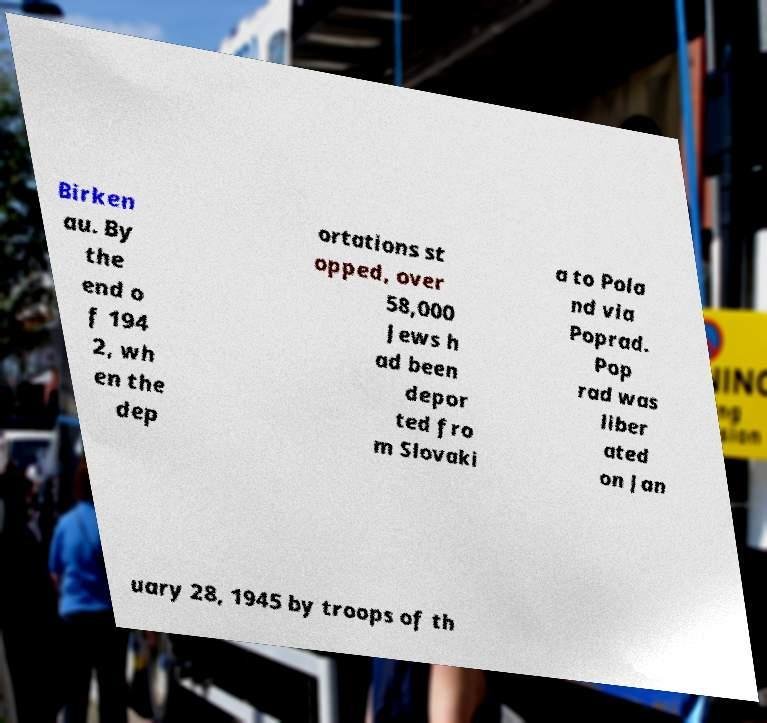I need the written content from this picture converted into text. Can you do that? Birken au. By the end o f 194 2, wh en the dep ortations st opped, over 58,000 Jews h ad been depor ted fro m Slovaki a to Pola nd via Poprad. Pop rad was liber ated on Jan uary 28, 1945 by troops of th 